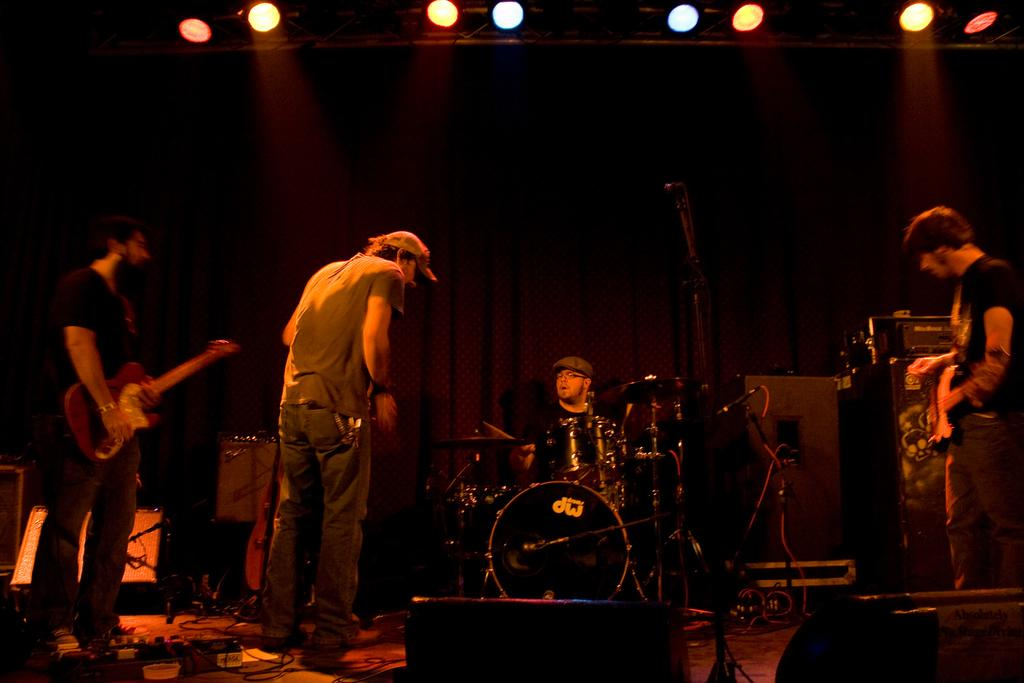What are the people on stage doing in the image? The people on stage are playing musical instruments. What types of musical instruments can be seen in the image? There are different types of musical instruments being played in the image. Can you describe the lighting in the image? There are lights visible at the top of the image. What type of knife is being used by the person playing the guitar in the image? There is no knife present in the image; the people are playing musical instruments, not using knives. 